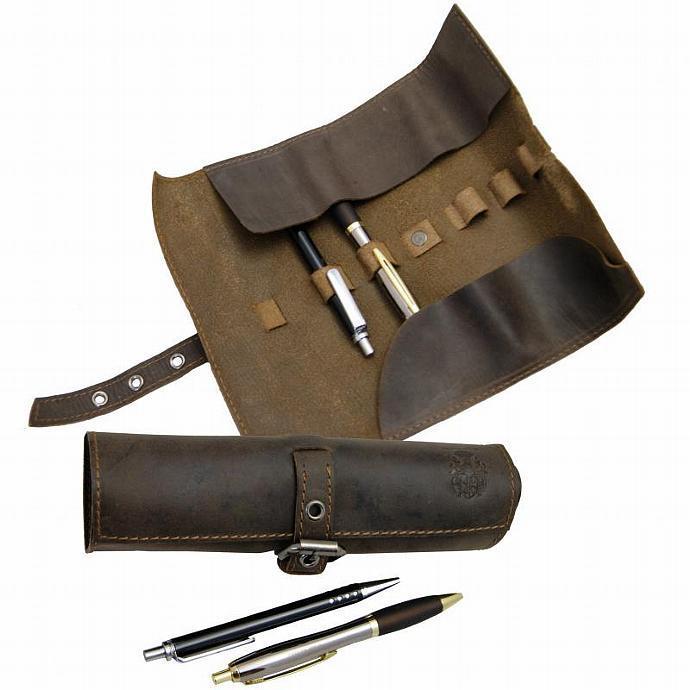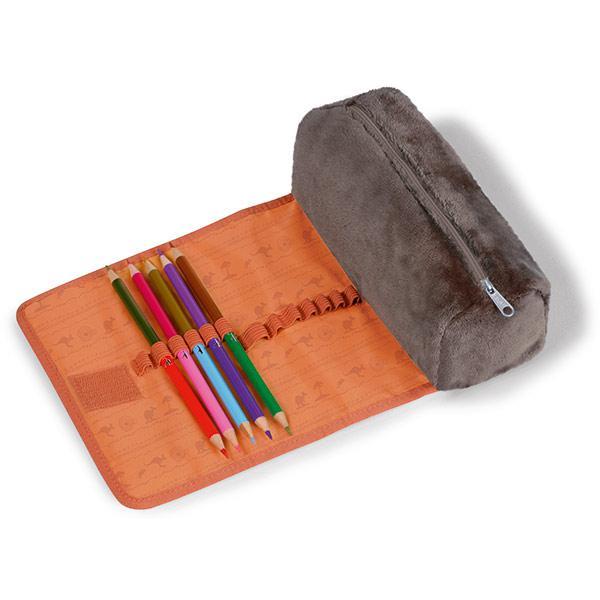The first image is the image on the left, the second image is the image on the right. Considering the images on both sides, is "An image shows one leather pencil case, displayed open with writing implements tucked inside." valid? Answer yes or no. No. The first image is the image on the left, the second image is the image on the right. For the images shown, is this caption "In one image, a leather pencil case is displayed closed in at least four colors, while the other image displays how a different brown case looks when opened." true? Answer yes or no. No. 